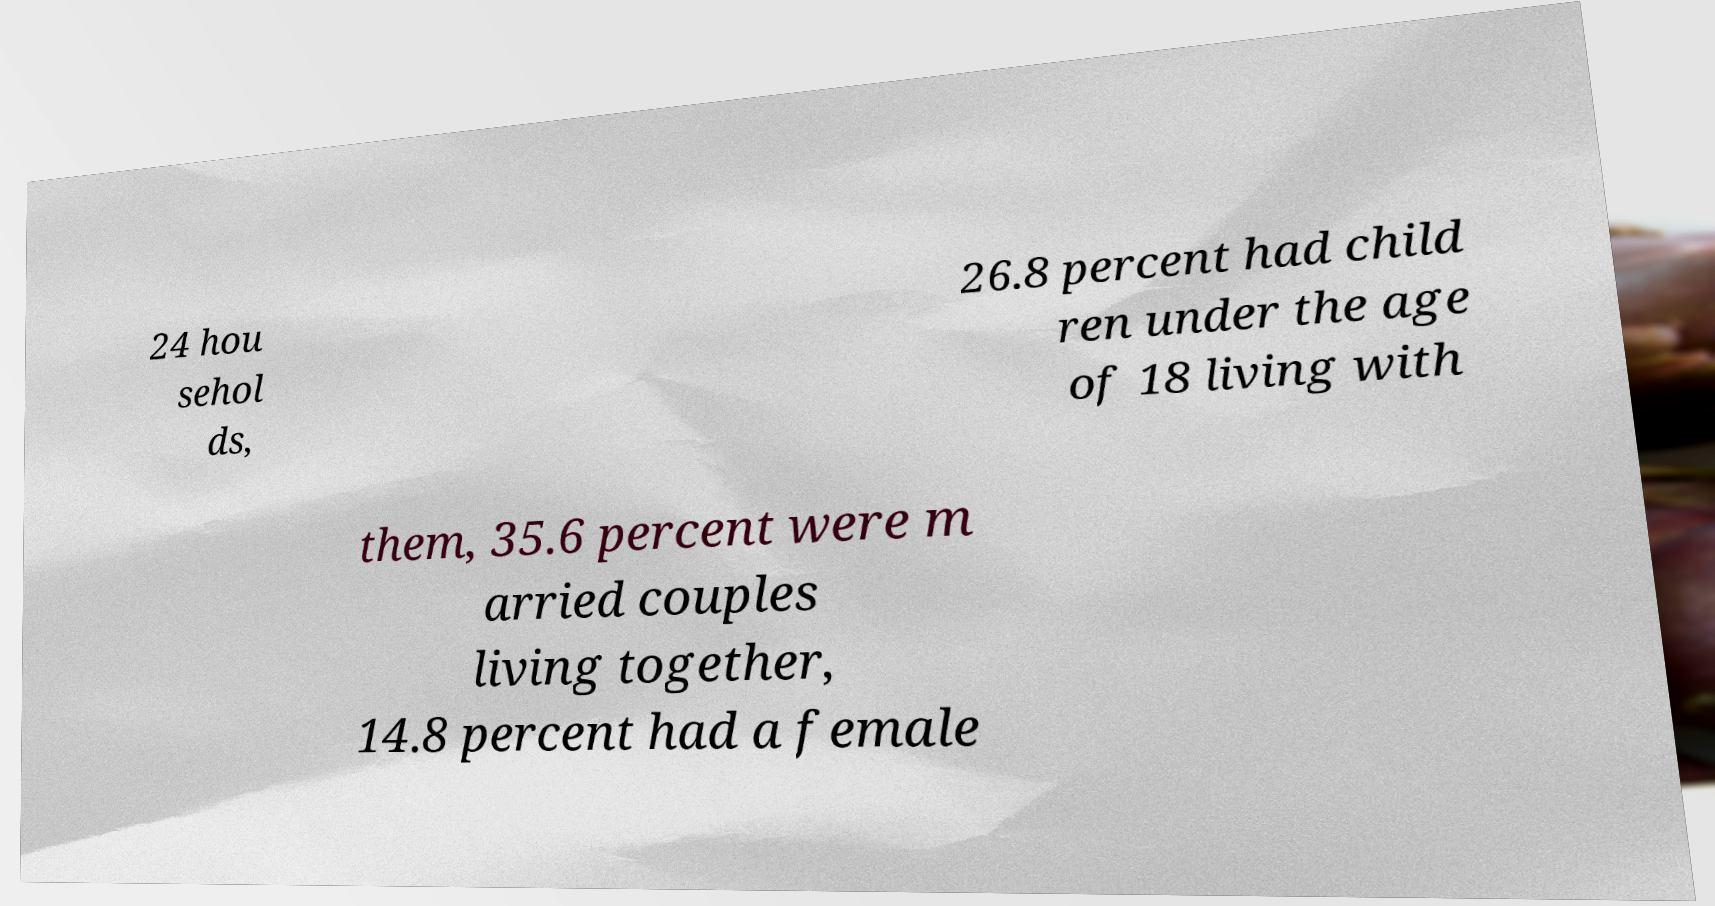There's text embedded in this image that I need extracted. Can you transcribe it verbatim? 24 hou sehol ds, 26.8 percent had child ren under the age of 18 living with them, 35.6 percent were m arried couples living together, 14.8 percent had a female 